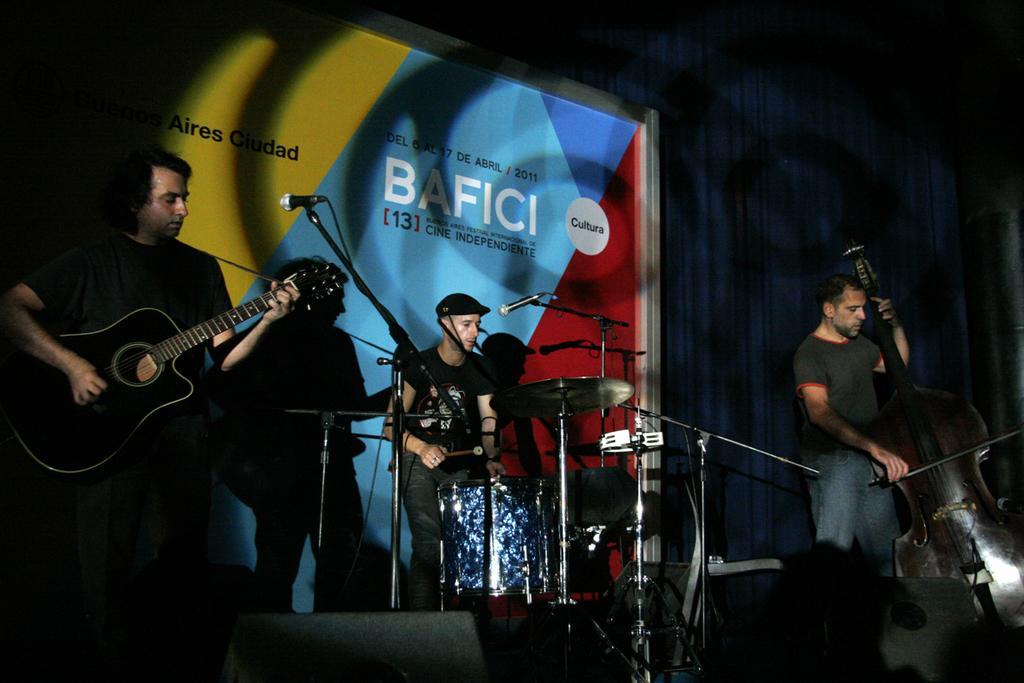Please provide a concise description of this image. In this image we can see a three persons who are performing on a stage. They are playing a guitar and singing on a microphone. 